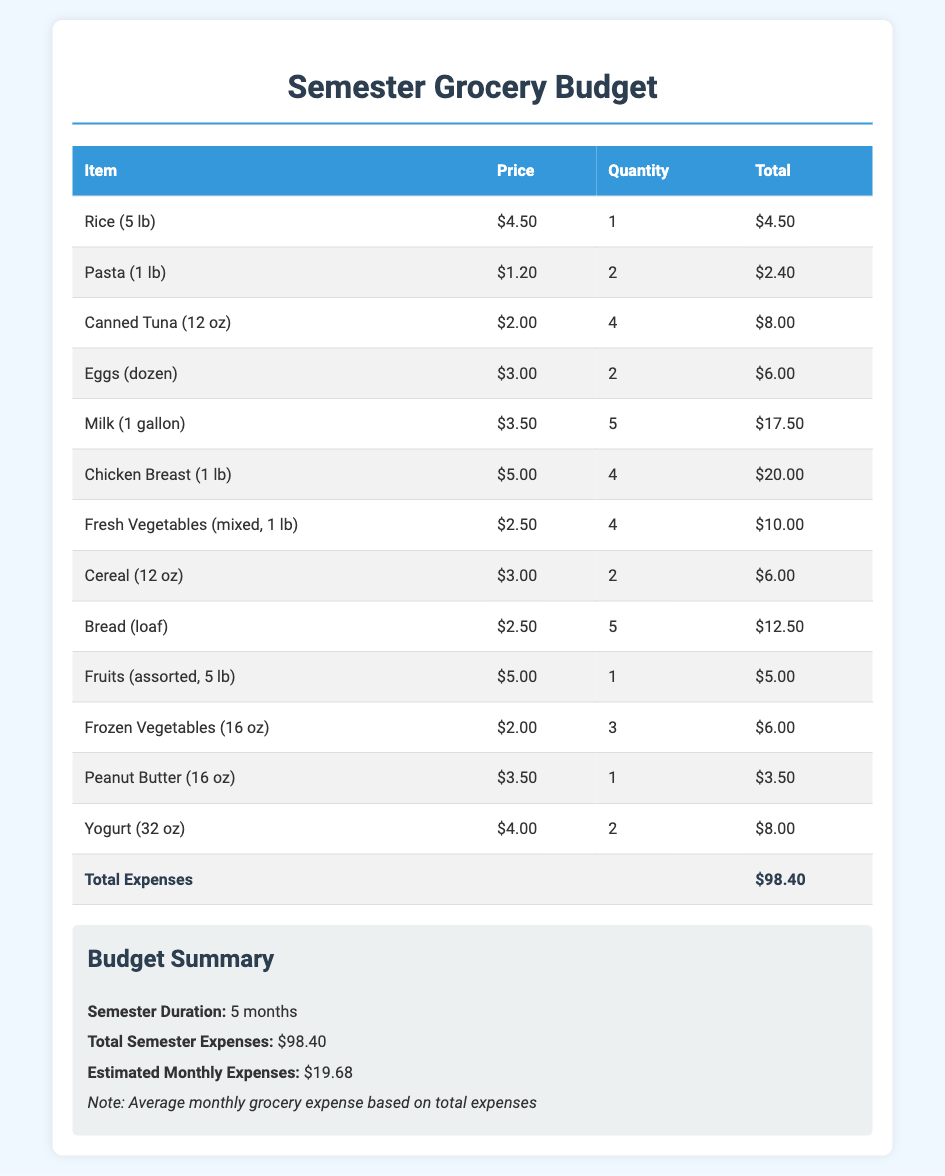What is the total grocery expense for the semester? The total expense is clearly listed in the document as the sum of all itemized purchases.
Answer: $98.40 How many pounds of chicken breast are purchased? The quantity purchased is indicated next to the chicken breast item in the table.
Answer: 4 What is the price of a loaf of bread? The price for bread (loaf) is provided in the price column of the table.
Answer: $2.50 How many gallons of milk are included in the budget? The quantity of milk is specified next to the milk item in the table.
Answer: 5 What is the estimated monthly expense? The estimated monthly expense is calculated by dividing the total semester expense by the number of months.
Answer: $19.68 What is the total quantity of canned tuna purchased? The quantity of canned tuna is shown in the quantity column of the table.
Answer: 4 How much is spent on fresh vegetables? The total price for fresh vegetables is indicated in the total column associated with the vegetable item.
Answer: $10.00 How many items are listed in the grocery budget? The number of items can be counted from the rows in the itemized table.
Answer: 13 What is the price of yogurt? The price for yogurt (32 oz) is listed under the price column in the table.
Answer: $4.00 